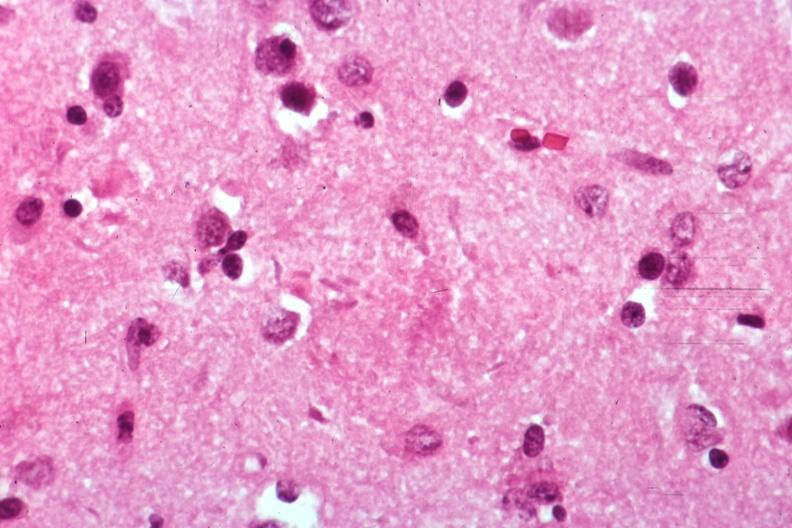s vasculature present?
Answer the question using a single word or phrase. No 